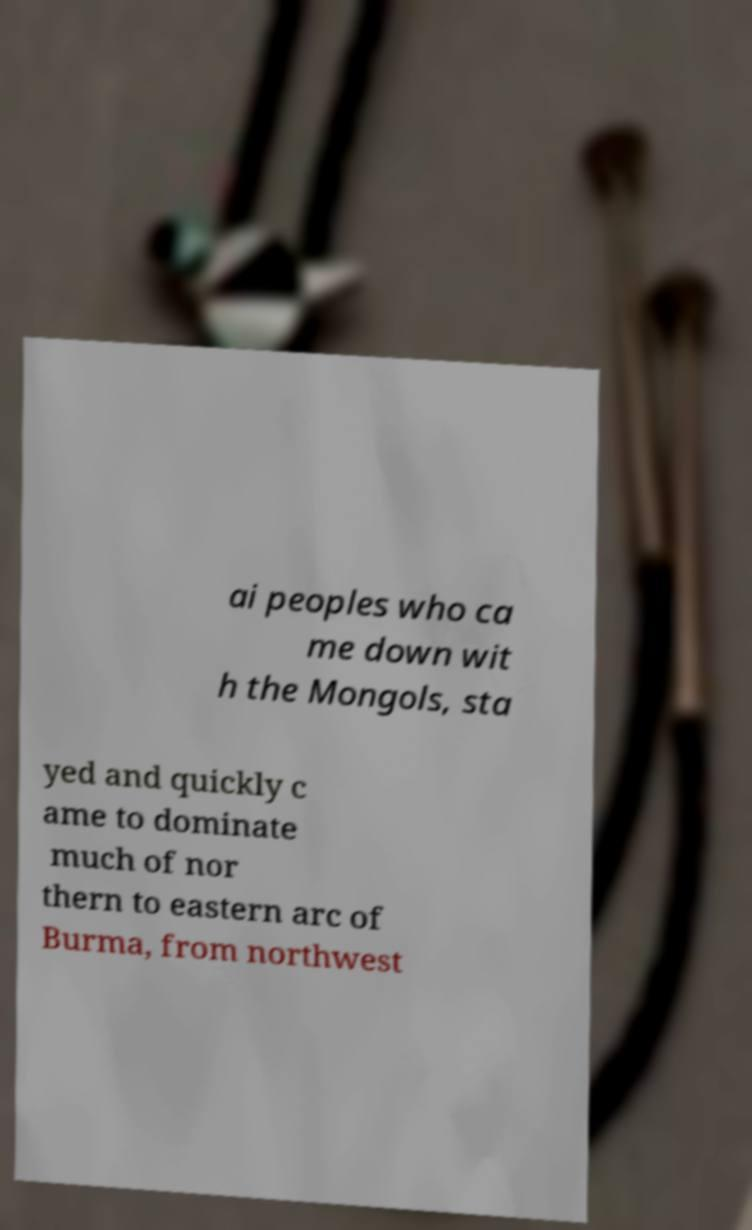Can you read and provide the text displayed in the image?This photo seems to have some interesting text. Can you extract and type it out for me? ai peoples who ca me down wit h the Mongols, sta yed and quickly c ame to dominate much of nor thern to eastern arc of Burma, from northwest 